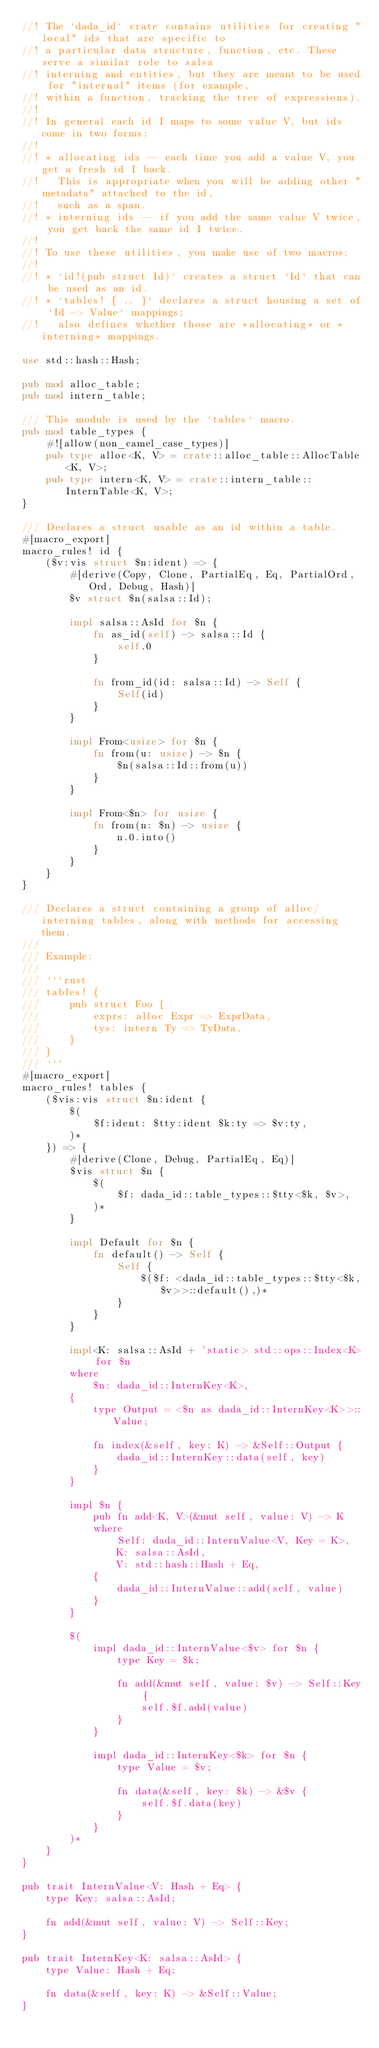<code> <loc_0><loc_0><loc_500><loc_500><_Rust_>//! The `dada_id` crate contains utilities for creating "local" ids that are specific to
//! a particular data structure, function, etc. These serve a similar role to salsa
//! interning and entities, but they are meant to be used for "internal" items (for example,
//! within a function, tracking the tree of expressions).
//!
//! In general each id I maps to some value V, but ids come in two forms:
//!
//! * allocating ids -- each time you add a value V, you get a fresh id I back.
//!   This is appropriate when you will be adding other "metadata" attached to the id,
//!   such as a span.
//! * interning ids -- if you add the same value V twice, you get back the same id I twice.
//!
//! To use these utilities, you make use of two macros:
//!
//! * `id!(pub struct Id)` creates a struct `Id` that can be used as an id.
//! * `tables! { .. }` declares a struct housing a set of `Id -> Value` mappings;
//!   also defines whether those are *allocating* or *interning* mappings.

use std::hash::Hash;

pub mod alloc_table;
pub mod intern_table;

/// This module is used by the `tables` macro.
pub mod table_types {
    #![allow(non_camel_case_types)]
    pub type alloc<K, V> = crate::alloc_table::AllocTable<K, V>;
    pub type intern<K, V> = crate::intern_table::InternTable<K, V>;
}

/// Declares a struct usable as an id within a table.
#[macro_export]
macro_rules! id {
    ($v:vis struct $n:ident) => {
        #[derive(Copy, Clone, PartialEq, Eq, PartialOrd, Ord, Debug, Hash)]
        $v struct $n(salsa::Id);

        impl salsa::AsId for $n {
            fn as_id(self) -> salsa::Id {
                self.0
            }

            fn from_id(id: salsa::Id) -> Self {
                Self(id)
            }
        }

        impl From<usize> for $n {
            fn from(u: usize) -> $n {
                $n(salsa::Id::from(u))
            }
        }

        impl From<$n> for usize {
            fn from(n: $n) -> usize {
                n.0.into()
            }
        }
    }
}

/// Declares a struct containing a group of alloc/interning tables, along with methods for accessing them.
///
/// Example:
///
/// ```rust
/// tables! {
///     pub struct Foo {
///         exprs: alloc Expr => ExprData,
///         tys: intern Ty => TyData,
///     }
/// }
/// ```
#[macro_export]
macro_rules! tables {
    ($vis:vis struct $n:ident {
        $(
            $f:ident: $tty:ident $k:ty => $v:ty,
        )*
    }) => {
        #[derive(Clone, Debug, PartialEq, Eq)]
        $vis struct $n {
            $(
                $f: dada_id::table_types::$tty<$k, $v>,
            )*
        }

        impl Default for $n {
            fn default() -> Self {
                Self {
                    $($f: <dada_id::table_types::$tty<$k,$v>>::default(),)*
                }
            }
        }

        impl<K: salsa::AsId + 'static> std::ops::Index<K> for $n
        where
            $n: dada_id::InternKey<K>,
        {
            type Output = <$n as dada_id::InternKey<K>>::Value;

            fn index(&self, key: K) -> &Self::Output {
                dada_id::InternKey::data(self, key)
            }
        }

        impl $n {
            pub fn add<K, V>(&mut self, value: V) -> K
            where
                Self: dada_id::InternValue<V, Key = K>,
                K: salsa::AsId,
                V: std::hash::Hash + Eq,
            {
                dada_id::InternValue::add(self, value)
            }
        }

        $(
            impl dada_id::InternValue<$v> for $n {
                type Key = $k;

                fn add(&mut self, value: $v) -> Self::Key {
                    self.$f.add(value)
                }
            }

            impl dada_id::InternKey<$k> for $n {
                type Value = $v;

                fn data(&self, key: $k) -> &$v {
                    self.$f.data(key)
                }
            }
        )*
    }
}

pub trait InternValue<V: Hash + Eq> {
    type Key: salsa::AsId;

    fn add(&mut self, value: V) -> Self::Key;
}

pub trait InternKey<K: salsa::AsId> {
    type Value: Hash + Eq;

    fn data(&self, key: K) -> &Self::Value;
}
</code> 